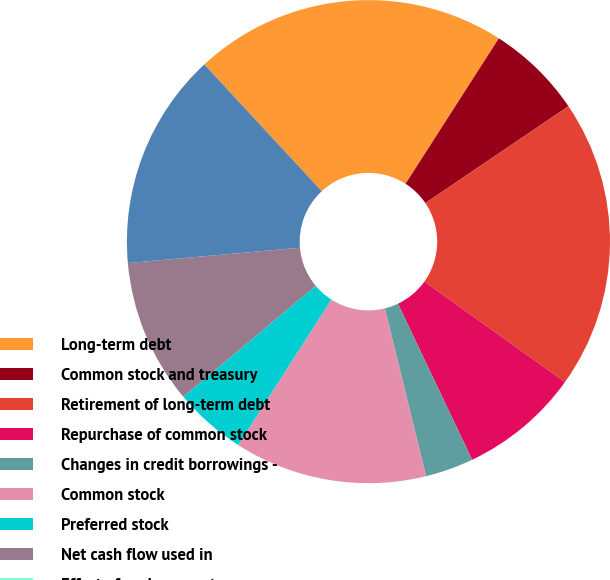Convert chart. <chart><loc_0><loc_0><loc_500><loc_500><pie_chart><fcel>Long-term debt<fcel>Common stock and treasury<fcel>Retirement of long-term debt<fcel>Repurchase of common stock<fcel>Changes in credit borrowings -<fcel>Common stock<fcel>Preferred stock<fcel>Net cash flow used in<fcel>Effect of exchange rates on<fcel>Net decrease in cash and cash<nl><fcel>20.97%<fcel>6.45%<fcel>19.35%<fcel>8.06%<fcel>3.23%<fcel>12.9%<fcel>4.84%<fcel>9.68%<fcel>0.0%<fcel>14.52%<nl></chart> 